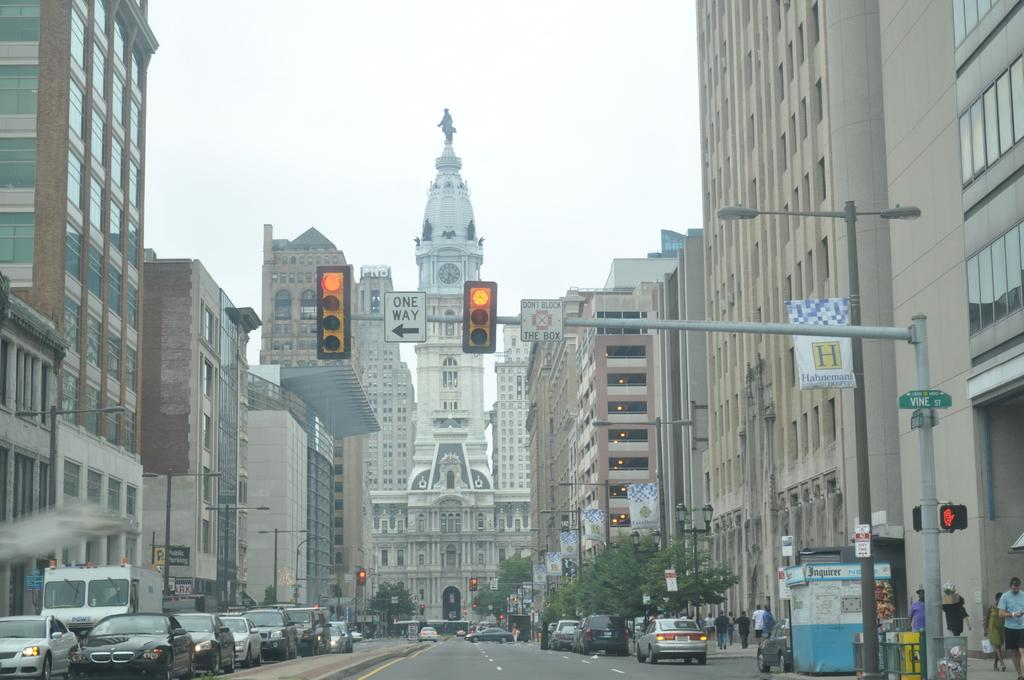<image>
Share a concise interpretation of the image provided. A red light has a white sign that says One Way above a downtown intersection. 